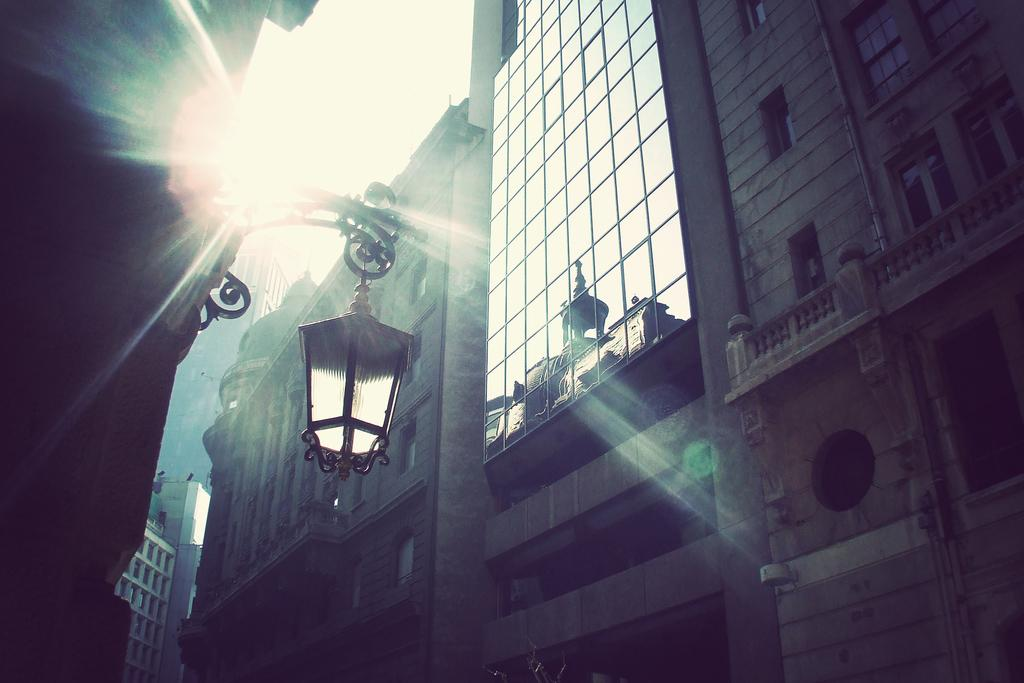What type of structures can be seen in the image? There are buildings in the image. Can you describe the lighting in the image? There is light visible in the image. What can be seen in the background of the image? The sky is visible in the background of the image. What type of letter is being written in the image? There is no letter being written in the image; it features buildings, light, and the sky. Can you see a wrench being used in the image? There is no wrench present in the image. 